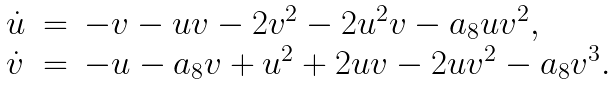Convert formula to latex. <formula><loc_0><loc_0><loc_500><loc_500>\begin{array} { l c l } \dot { u } & = & - v - u v - 2 v ^ { 2 } - 2 u ^ { 2 } v - a _ { 8 } u v ^ { 2 } , \\ \dot { v } & = & - u - a _ { 8 } v + u ^ { 2 } + 2 u v - 2 u v ^ { 2 } - a _ { 8 } v ^ { 3 } . \end{array}</formula> 